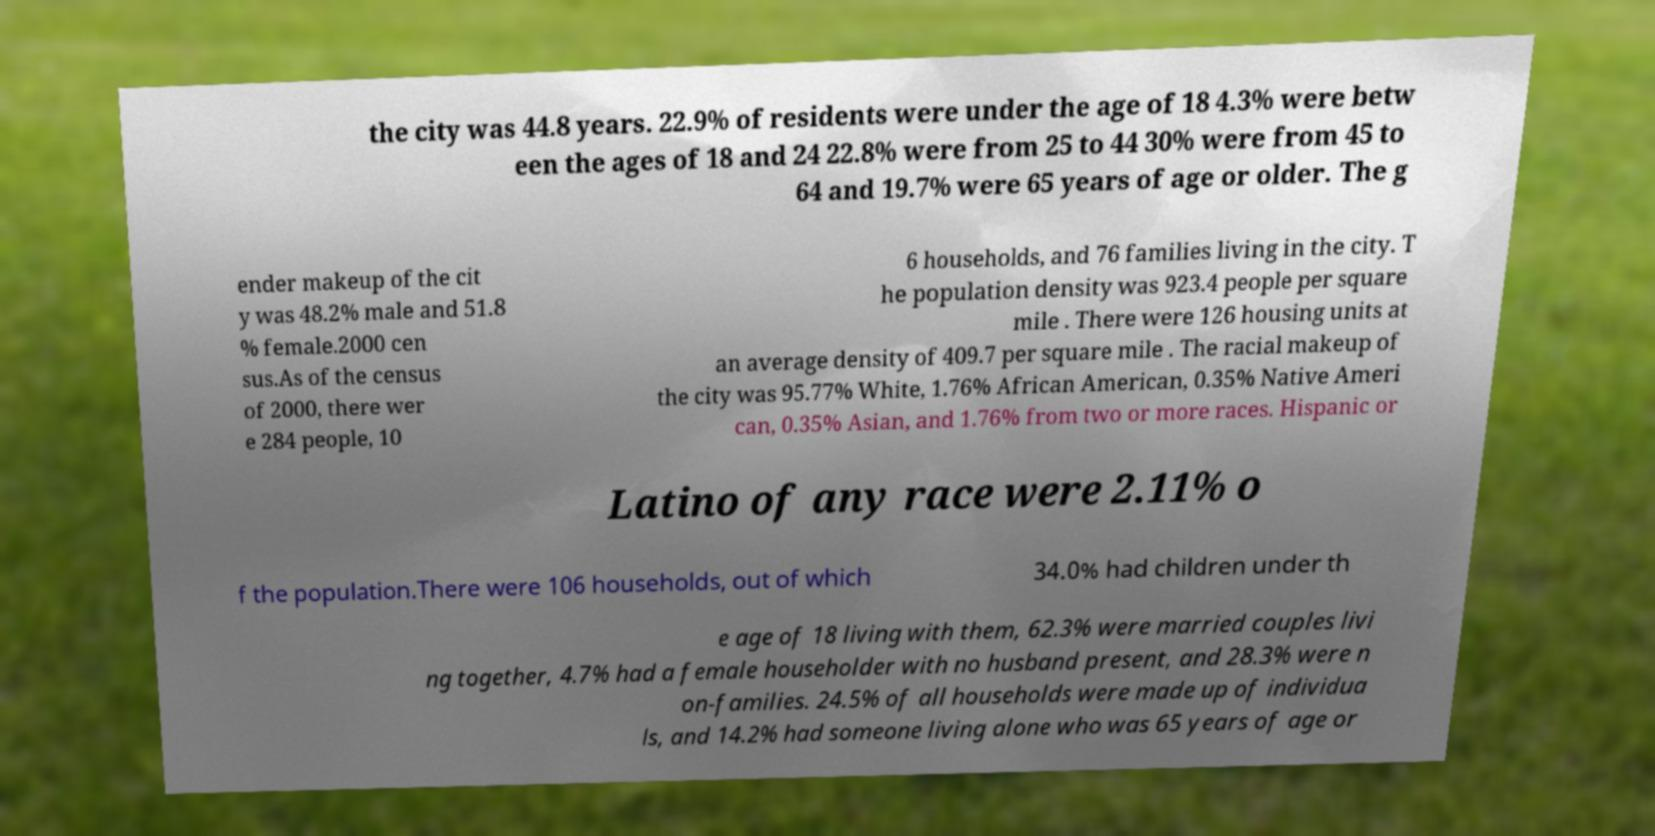Could you assist in decoding the text presented in this image and type it out clearly? the city was 44.8 years. 22.9% of residents were under the age of 18 4.3% were betw een the ages of 18 and 24 22.8% were from 25 to 44 30% were from 45 to 64 and 19.7% were 65 years of age or older. The g ender makeup of the cit y was 48.2% male and 51.8 % female.2000 cen sus.As of the census of 2000, there wer e 284 people, 10 6 households, and 76 families living in the city. T he population density was 923.4 people per square mile . There were 126 housing units at an average density of 409.7 per square mile . The racial makeup of the city was 95.77% White, 1.76% African American, 0.35% Native Ameri can, 0.35% Asian, and 1.76% from two or more races. Hispanic or Latino of any race were 2.11% o f the population.There were 106 households, out of which 34.0% had children under th e age of 18 living with them, 62.3% were married couples livi ng together, 4.7% had a female householder with no husband present, and 28.3% were n on-families. 24.5% of all households were made up of individua ls, and 14.2% had someone living alone who was 65 years of age or 